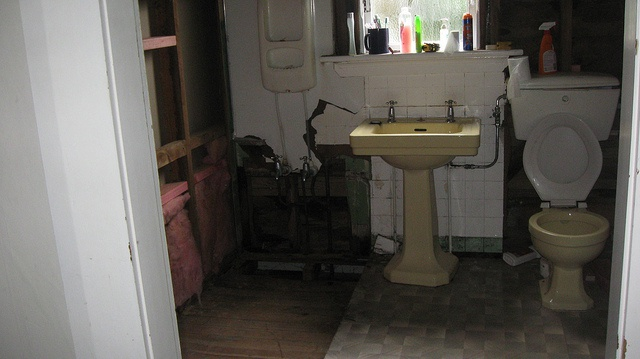Describe the objects in this image and their specific colors. I can see toilet in gray and black tones, sink in gray and black tones, bottle in gray, black, and maroon tones, bottle in gray, white, and salmon tones, and cup in gray, black, and darkgray tones in this image. 